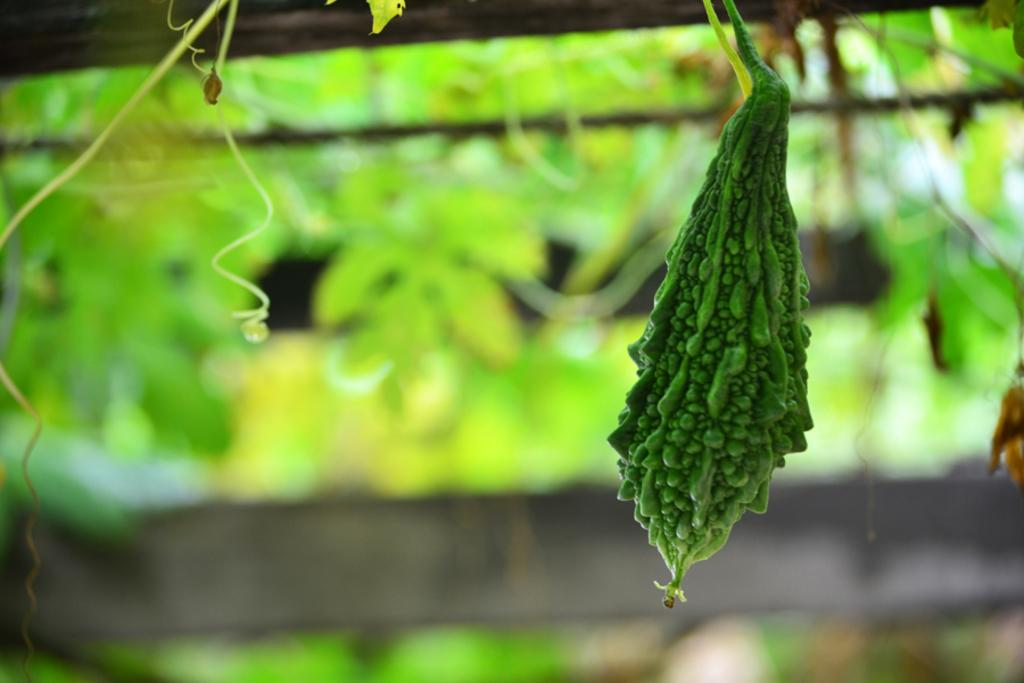What is the main subject of the image? There is a bitter gourd in the image. How would you describe the background of the image? The background of the image is blurred. What can be seen in the blurred background? There are leaves and a wooden fence visible in the background. What number is written on the scale in the image? There is no scale present in the image, so it is not possible to determine the number written on it. 